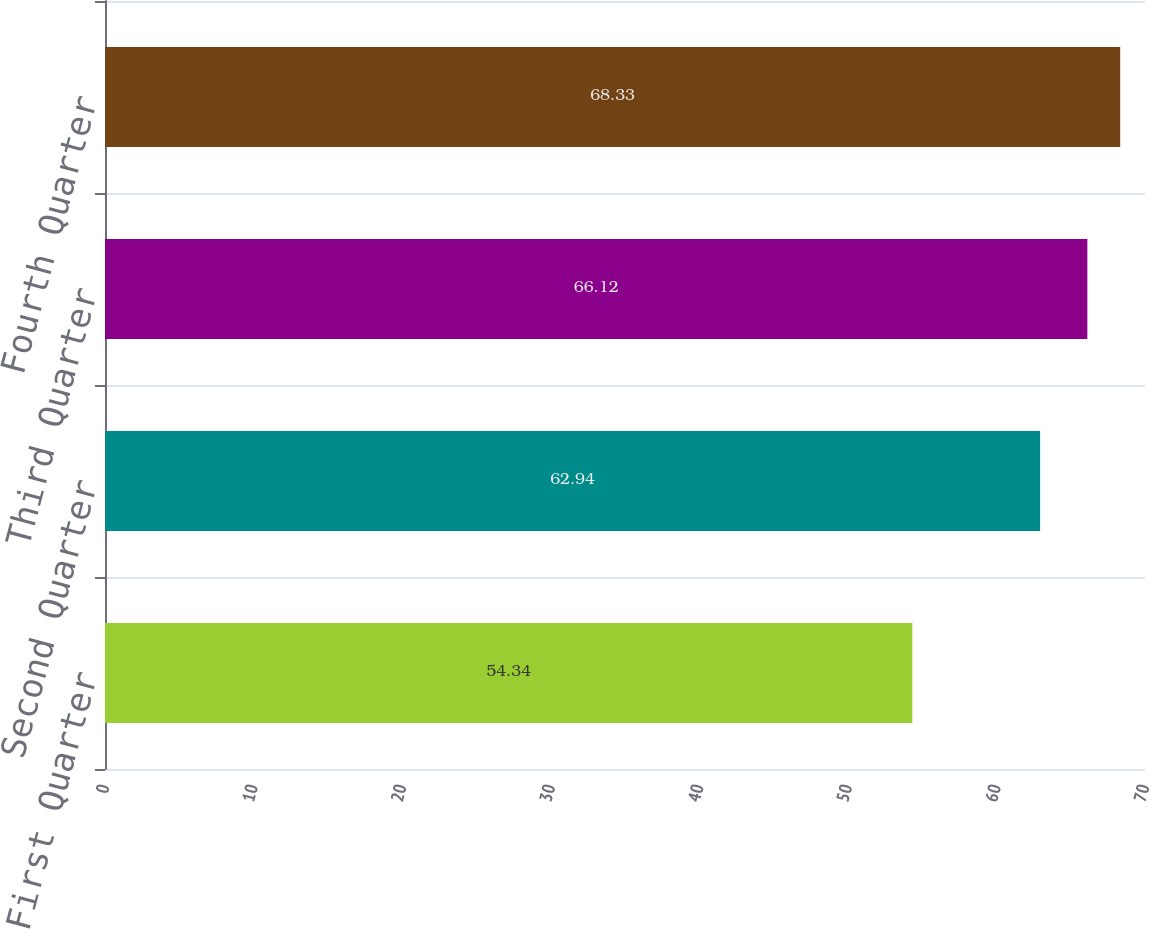Convert chart to OTSL. <chart><loc_0><loc_0><loc_500><loc_500><bar_chart><fcel>First Quarter<fcel>Second Quarter<fcel>Third Quarter<fcel>Fourth Quarter<nl><fcel>54.34<fcel>62.94<fcel>66.12<fcel>68.33<nl></chart> 